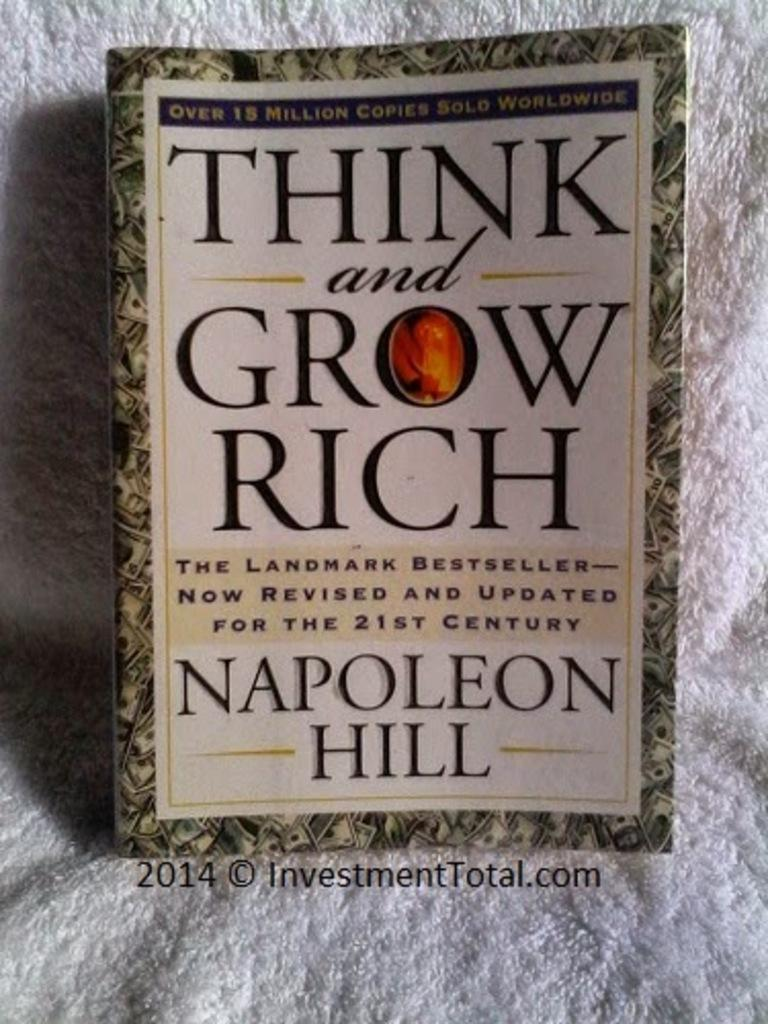<image>
Provide a brief description of the given image. A book called Think and Grow Rich by Napoleon Hill 